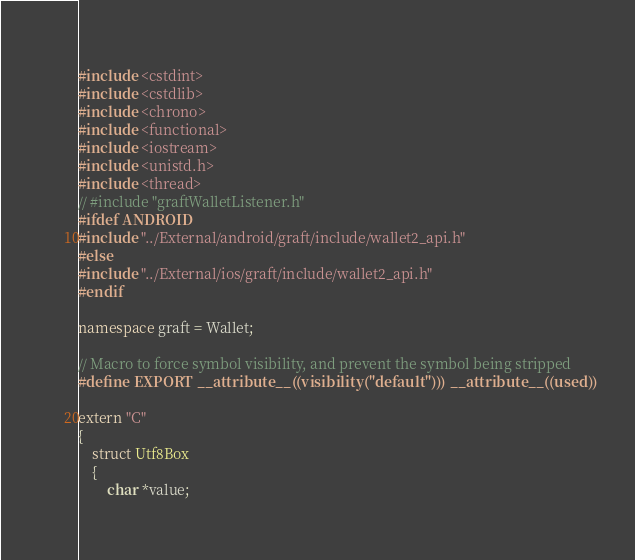Convert code to text. <code><loc_0><loc_0><loc_500><loc_500><_C++_>#include <cstdint>
#include <cstdlib>
#include <chrono>
#include <functional>
#include <iostream>
#include <unistd.h>
#include <thread>
// #include "graftWalletListener.h"
#ifdef ANDROID
#include "../External/android/graft/include/wallet2_api.h"
#else
#include "../External/ios/graft/include/wallet2_api.h"
#endif

namespace graft = Wallet;

// Macro to force symbol visibility, and prevent the symbol being stripped
#define EXPORT __attribute__((visibility("default"))) __attribute__((used))

extern "C"
{
    struct Utf8Box
    {
        char *value;
</code> 